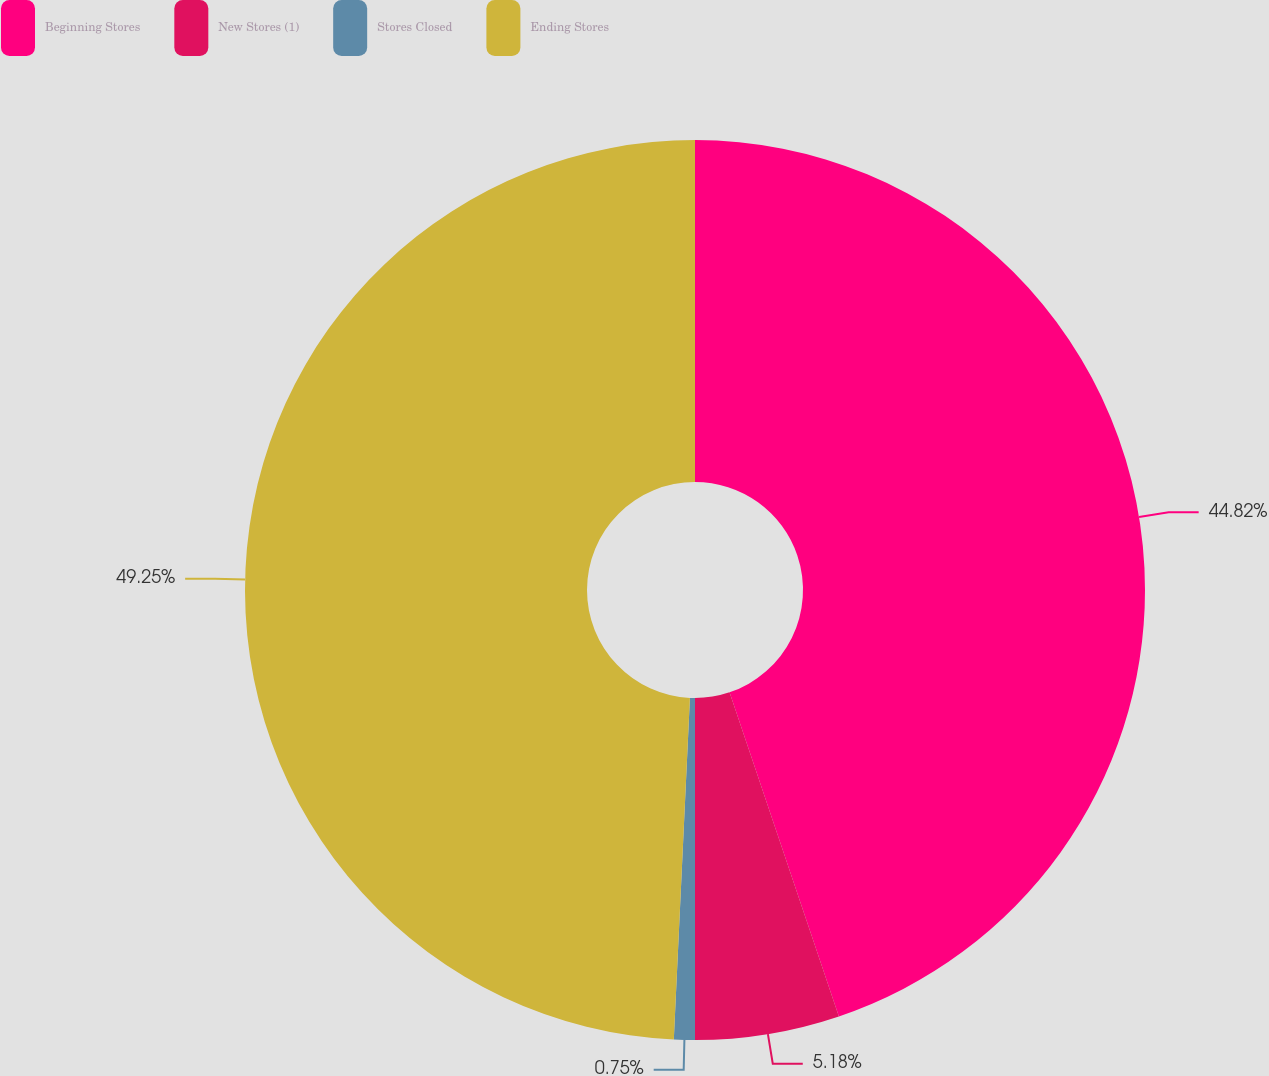<chart> <loc_0><loc_0><loc_500><loc_500><pie_chart><fcel>Beginning Stores<fcel>New Stores (1)<fcel>Stores Closed<fcel>Ending Stores<nl><fcel>44.82%<fcel>5.18%<fcel>0.75%<fcel>49.25%<nl></chart> 